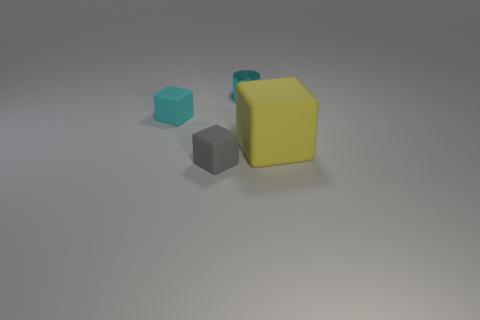What number of other objects are the same color as the big rubber object?
Offer a very short reply. 0. Is there anything else that has the same shape as the shiny thing?
Offer a terse response. No. There is another small object that is the same shape as the small gray object; what is its color?
Your answer should be very brief. Cyan. The small block that is made of the same material as the tiny gray object is what color?
Offer a very short reply. Cyan. Are there an equal number of cyan objects on the right side of the cyan block and large yellow matte cubes?
Your answer should be compact. Yes. There is a cube that is left of the gray cube; is its size the same as the tiny cylinder?
Your answer should be compact. Yes. There is another rubber block that is the same size as the cyan matte cube; what is its color?
Provide a succinct answer. Gray. Is there a cyan thing that is behind the tiny object left of the matte object that is in front of the large yellow thing?
Your answer should be compact. Yes. What is the tiny object on the right side of the gray block made of?
Give a very brief answer. Metal. There is a metallic thing; is its shape the same as the tiny rubber thing that is behind the big matte block?
Your response must be concise. No. 